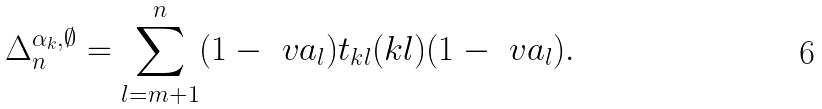Convert formula to latex. <formula><loc_0><loc_0><loc_500><loc_500>\Delta _ { n } ^ { \alpha _ { k } , \emptyset } = \sum _ { l = m + 1 } ^ { n } ( 1 - \ v a _ { l } ) t _ { k l } ( k l ) ( 1 - \ v a _ { l } ) .</formula> 